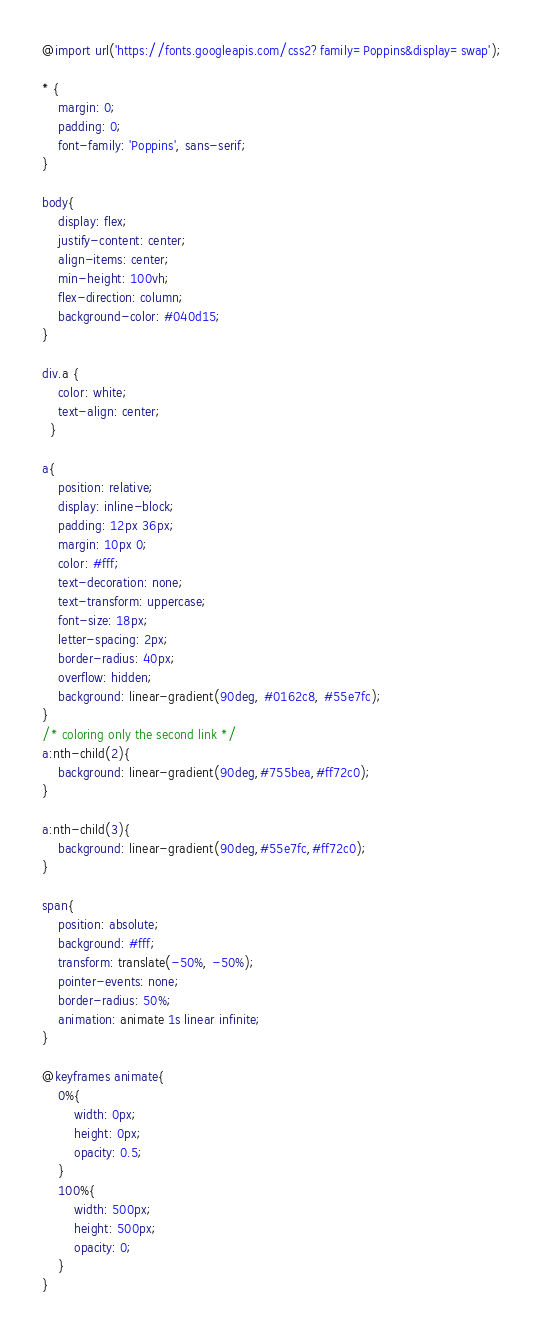<code> <loc_0><loc_0><loc_500><loc_500><_CSS_>@import url('https://fonts.googleapis.com/css2?family=Poppins&display=swap');

* {
    margin: 0;
    padding: 0;
    font-family: 'Poppins', sans-serif;
}

body{
    display: flex;
    justify-content: center;
    align-items: center;
    min-height: 100vh;
    flex-direction: column;
    background-color: #040d15;
}

div.a {
    color: white;
    text-align: center;
  }

a{
    position: relative;
    display: inline-block;
    padding: 12px 36px;
    margin: 10px 0;
    color: #fff;
    text-decoration: none;
    text-transform: uppercase;
    font-size: 18px;
    letter-spacing: 2px;
    border-radius: 40px;
    overflow: hidden;
    background: linear-gradient(90deg, #0162c8, #55e7fc);
}
/* coloring only the second link */
a:nth-child(2){
    background: linear-gradient(90deg,#755bea,#ff72c0);
}

a:nth-child(3){
    background: linear-gradient(90deg,#55e7fc,#ff72c0);
}

span{
    position: absolute;
    background: #fff;
    transform: translate(-50%, -50%);
    pointer-events: none;
    border-radius: 50%;
    animation: animate 1s linear infinite;
}

@keyframes animate{
    0%{
        width: 0px;
        height: 0px;
        opacity: 0.5;
    }
    100%{
        width: 500px;
        height: 500px;
        opacity: 0;
    }
}
</code> 